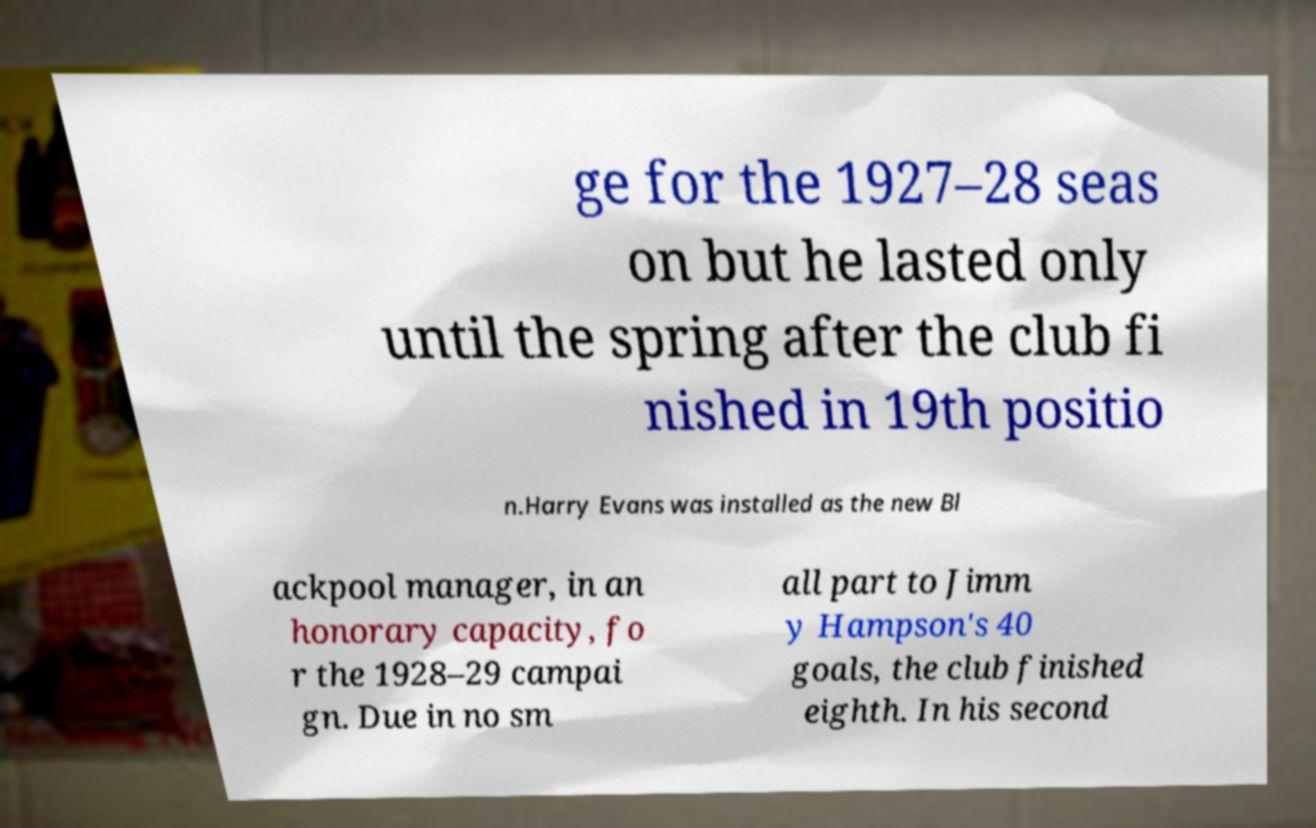Can you accurately transcribe the text from the provided image for me? ge for the 1927–28 seas on but he lasted only until the spring after the club fi nished in 19th positio n.Harry Evans was installed as the new Bl ackpool manager, in an honorary capacity, fo r the 1928–29 campai gn. Due in no sm all part to Jimm y Hampson's 40 goals, the club finished eighth. In his second 